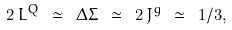<formula> <loc_0><loc_0><loc_500><loc_500>2 \, L ^ { Q } \ \simeq \ \Delta \Sigma \ \simeq \ 2 \, J ^ { g } \ \simeq \ 1 / 3 ,</formula> 